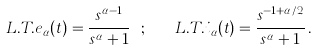<formula> <loc_0><loc_0><loc_500><loc_500>L . T . e _ { \alpha } ( t ) = \frac { s ^ { \alpha - 1 } } { s ^ { \alpha } + 1 } \ ; \quad L . T . i _ { \alpha } ( t ) = \frac { s ^ { - 1 + \alpha / 2 } } { s ^ { \alpha } + 1 } \, .</formula> 